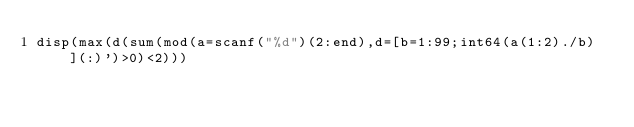<code> <loc_0><loc_0><loc_500><loc_500><_Octave_>disp(max(d(sum(mod(a=scanf("%d")(2:end),d=[b=1:99;int64(a(1:2)./b)](:)')>0)<2)))</code> 